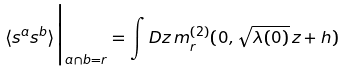<formula> <loc_0><loc_0><loc_500><loc_500>\langle s ^ { a } s ^ { b } \rangle \Big | _ { a \cap b = r } = \int D z \, m _ { r } ^ { ( 2 ) } ( 0 , \sqrt { \lambda ( 0 ) } \, z + h )</formula> 